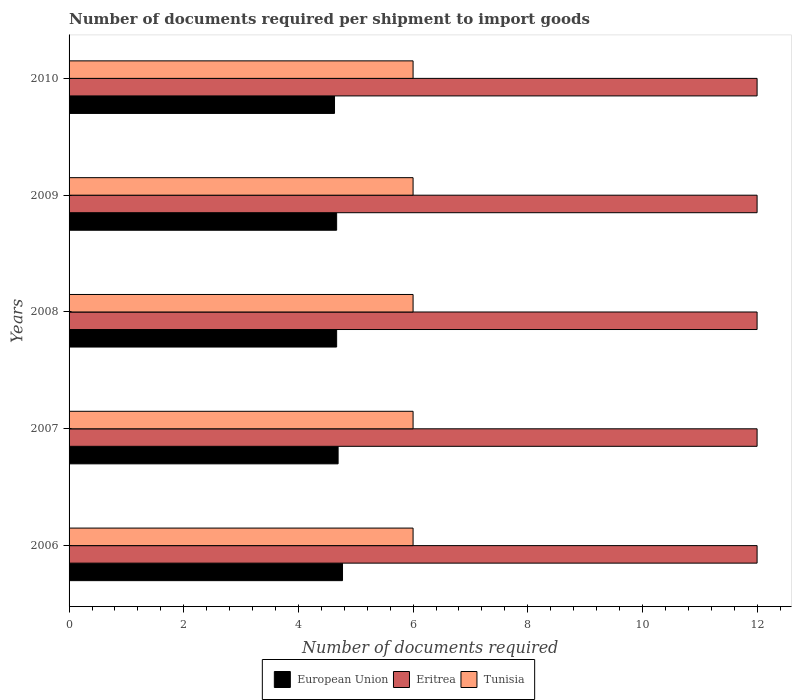How many different coloured bars are there?
Keep it short and to the point. 3. Are the number of bars per tick equal to the number of legend labels?
Offer a terse response. Yes. Are the number of bars on each tick of the Y-axis equal?
Provide a short and direct response. Yes. What is the label of the 3rd group of bars from the top?
Ensure brevity in your answer.  2008. In how many cases, is the number of bars for a given year not equal to the number of legend labels?
Ensure brevity in your answer.  0. What is the number of documents required per shipment to import goods in Eritrea in 2009?
Provide a short and direct response. 12. Across all years, what is the maximum number of documents required per shipment to import goods in Eritrea?
Your response must be concise. 12. Across all years, what is the minimum number of documents required per shipment to import goods in Eritrea?
Your response must be concise. 12. In which year was the number of documents required per shipment to import goods in Tunisia maximum?
Ensure brevity in your answer.  2006. In which year was the number of documents required per shipment to import goods in Eritrea minimum?
Offer a terse response. 2006. What is the total number of documents required per shipment to import goods in Eritrea in the graph?
Offer a very short reply. 60. What is the difference between the number of documents required per shipment to import goods in Eritrea in 2006 and that in 2007?
Provide a succinct answer. 0. What is the difference between the number of documents required per shipment to import goods in Tunisia in 2008 and the number of documents required per shipment to import goods in Eritrea in 2007?
Provide a succinct answer. -6. What is the average number of documents required per shipment to import goods in Eritrea per year?
Give a very brief answer. 12. In the year 2007, what is the difference between the number of documents required per shipment to import goods in Eritrea and number of documents required per shipment to import goods in European Union?
Provide a short and direct response. 7.31. In how many years, is the number of documents required per shipment to import goods in Eritrea greater than 0.4 ?
Your answer should be compact. 5. Is the number of documents required per shipment to import goods in Eritrea in 2006 less than that in 2007?
Ensure brevity in your answer.  No. What is the difference between the highest and the second highest number of documents required per shipment to import goods in European Union?
Your answer should be very brief. 0.08. What is the difference between the highest and the lowest number of documents required per shipment to import goods in Eritrea?
Your answer should be very brief. 0. What does the 1st bar from the top in 2006 represents?
Offer a terse response. Tunisia. What does the 2nd bar from the bottom in 2006 represents?
Your answer should be compact. Eritrea. How many years are there in the graph?
Provide a short and direct response. 5. Are the values on the major ticks of X-axis written in scientific E-notation?
Offer a very short reply. No. How many legend labels are there?
Make the answer very short. 3. How are the legend labels stacked?
Your response must be concise. Horizontal. What is the title of the graph?
Your answer should be very brief. Number of documents required per shipment to import goods. What is the label or title of the X-axis?
Keep it short and to the point. Number of documents required. What is the Number of documents required in European Union in 2006?
Keep it short and to the point. 4.77. What is the Number of documents required of European Union in 2007?
Ensure brevity in your answer.  4.69. What is the Number of documents required of Eritrea in 2007?
Offer a very short reply. 12. What is the Number of documents required of Tunisia in 2007?
Keep it short and to the point. 6. What is the Number of documents required in European Union in 2008?
Provide a short and direct response. 4.67. What is the Number of documents required in Tunisia in 2008?
Offer a very short reply. 6. What is the Number of documents required in European Union in 2009?
Provide a short and direct response. 4.67. What is the Number of documents required in Tunisia in 2009?
Offer a terse response. 6. What is the Number of documents required in European Union in 2010?
Your answer should be compact. 4.63. What is the Number of documents required in Eritrea in 2010?
Make the answer very short. 12. Across all years, what is the maximum Number of documents required in European Union?
Ensure brevity in your answer.  4.77. Across all years, what is the maximum Number of documents required of Eritrea?
Make the answer very short. 12. Across all years, what is the maximum Number of documents required of Tunisia?
Provide a succinct answer. 6. Across all years, what is the minimum Number of documents required in European Union?
Ensure brevity in your answer.  4.63. Across all years, what is the minimum Number of documents required in Eritrea?
Ensure brevity in your answer.  12. Across all years, what is the minimum Number of documents required in Tunisia?
Give a very brief answer. 6. What is the total Number of documents required in European Union in the graph?
Provide a short and direct response. 23.42. What is the difference between the Number of documents required in European Union in 2006 and that in 2007?
Provide a short and direct response. 0.08. What is the difference between the Number of documents required in European Union in 2006 and that in 2008?
Offer a very short reply. 0.1. What is the difference between the Number of documents required in Eritrea in 2006 and that in 2008?
Make the answer very short. 0. What is the difference between the Number of documents required in Tunisia in 2006 and that in 2008?
Your answer should be very brief. 0. What is the difference between the Number of documents required in European Union in 2006 and that in 2009?
Offer a very short reply. 0.1. What is the difference between the Number of documents required in Eritrea in 2006 and that in 2009?
Keep it short and to the point. 0. What is the difference between the Number of documents required in European Union in 2006 and that in 2010?
Offer a very short reply. 0.14. What is the difference between the Number of documents required of Eritrea in 2006 and that in 2010?
Provide a short and direct response. 0. What is the difference between the Number of documents required of European Union in 2007 and that in 2008?
Offer a terse response. 0.03. What is the difference between the Number of documents required in European Union in 2007 and that in 2009?
Offer a terse response. 0.03. What is the difference between the Number of documents required of Eritrea in 2007 and that in 2009?
Your answer should be very brief. 0. What is the difference between the Number of documents required of Tunisia in 2007 and that in 2009?
Provide a short and direct response. 0. What is the difference between the Number of documents required in European Union in 2007 and that in 2010?
Your answer should be compact. 0.06. What is the difference between the Number of documents required of Eritrea in 2007 and that in 2010?
Your response must be concise. 0. What is the difference between the Number of documents required of Tunisia in 2007 and that in 2010?
Offer a very short reply. 0. What is the difference between the Number of documents required of European Union in 2008 and that in 2009?
Your response must be concise. 0. What is the difference between the Number of documents required of European Union in 2008 and that in 2010?
Your response must be concise. 0.04. What is the difference between the Number of documents required in European Union in 2009 and that in 2010?
Give a very brief answer. 0.04. What is the difference between the Number of documents required of Tunisia in 2009 and that in 2010?
Your answer should be compact. 0. What is the difference between the Number of documents required of European Union in 2006 and the Number of documents required of Eritrea in 2007?
Keep it short and to the point. -7.23. What is the difference between the Number of documents required of European Union in 2006 and the Number of documents required of Tunisia in 2007?
Provide a succinct answer. -1.23. What is the difference between the Number of documents required in Eritrea in 2006 and the Number of documents required in Tunisia in 2007?
Your answer should be very brief. 6. What is the difference between the Number of documents required in European Union in 2006 and the Number of documents required in Eritrea in 2008?
Keep it short and to the point. -7.23. What is the difference between the Number of documents required in European Union in 2006 and the Number of documents required in Tunisia in 2008?
Provide a succinct answer. -1.23. What is the difference between the Number of documents required in European Union in 2006 and the Number of documents required in Eritrea in 2009?
Make the answer very short. -7.23. What is the difference between the Number of documents required of European Union in 2006 and the Number of documents required of Tunisia in 2009?
Your answer should be compact. -1.23. What is the difference between the Number of documents required in European Union in 2006 and the Number of documents required in Eritrea in 2010?
Your response must be concise. -7.23. What is the difference between the Number of documents required of European Union in 2006 and the Number of documents required of Tunisia in 2010?
Offer a very short reply. -1.23. What is the difference between the Number of documents required of Eritrea in 2006 and the Number of documents required of Tunisia in 2010?
Provide a short and direct response. 6. What is the difference between the Number of documents required of European Union in 2007 and the Number of documents required of Eritrea in 2008?
Give a very brief answer. -7.31. What is the difference between the Number of documents required of European Union in 2007 and the Number of documents required of Tunisia in 2008?
Give a very brief answer. -1.31. What is the difference between the Number of documents required of Eritrea in 2007 and the Number of documents required of Tunisia in 2008?
Make the answer very short. 6. What is the difference between the Number of documents required in European Union in 2007 and the Number of documents required in Eritrea in 2009?
Make the answer very short. -7.31. What is the difference between the Number of documents required in European Union in 2007 and the Number of documents required in Tunisia in 2009?
Provide a short and direct response. -1.31. What is the difference between the Number of documents required of Eritrea in 2007 and the Number of documents required of Tunisia in 2009?
Your answer should be very brief. 6. What is the difference between the Number of documents required of European Union in 2007 and the Number of documents required of Eritrea in 2010?
Your answer should be very brief. -7.31. What is the difference between the Number of documents required in European Union in 2007 and the Number of documents required in Tunisia in 2010?
Your response must be concise. -1.31. What is the difference between the Number of documents required in Eritrea in 2007 and the Number of documents required in Tunisia in 2010?
Give a very brief answer. 6. What is the difference between the Number of documents required in European Union in 2008 and the Number of documents required in Eritrea in 2009?
Offer a terse response. -7.33. What is the difference between the Number of documents required in European Union in 2008 and the Number of documents required in Tunisia in 2009?
Provide a succinct answer. -1.33. What is the difference between the Number of documents required of European Union in 2008 and the Number of documents required of Eritrea in 2010?
Your answer should be compact. -7.33. What is the difference between the Number of documents required in European Union in 2008 and the Number of documents required in Tunisia in 2010?
Offer a terse response. -1.33. What is the difference between the Number of documents required of Eritrea in 2008 and the Number of documents required of Tunisia in 2010?
Ensure brevity in your answer.  6. What is the difference between the Number of documents required in European Union in 2009 and the Number of documents required in Eritrea in 2010?
Your response must be concise. -7.33. What is the difference between the Number of documents required of European Union in 2009 and the Number of documents required of Tunisia in 2010?
Offer a terse response. -1.33. What is the difference between the Number of documents required of Eritrea in 2009 and the Number of documents required of Tunisia in 2010?
Ensure brevity in your answer.  6. What is the average Number of documents required in European Union per year?
Provide a succinct answer. 4.68. What is the average Number of documents required of Tunisia per year?
Your answer should be compact. 6. In the year 2006, what is the difference between the Number of documents required of European Union and Number of documents required of Eritrea?
Your response must be concise. -7.23. In the year 2006, what is the difference between the Number of documents required in European Union and Number of documents required in Tunisia?
Your answer should be compact. -1.23. In the year 2006, what is the difference between the Number of documents required of Eritrea and Number of documents required of Tunisia?
Your response must be concise. 6. In the year 2007, what is the difference between the Number of documents required of European Union and Number of documents required of Eritrea?
Offer a terse response. -7.31. In the year 2007, what is the difference between the Number of documents required of European Union and Number of documents required of Tunisia?
Ensure brevity in your answer.  -1.31. In the year 2007, what is the difference between the Number of documents required in Eritrea and Number of documents required in Tunisia?
Make the answer very short. 6. In the year 2008, what is the difference between the Number of documents required in European Union and Number of documents required in Eritrea?
Make the answer very short. -7.33. In the year 2008, what is the difference between the Number of documents required in European Union and Number of documents required in Tunisia?
Offer a terse response. -1.33. In the year 2008, what is the difference between the Number of documents required in Eritrea and Number of documents required in Tunisia?
Your answer should be compact. 6. In the year 2009, what is the difference between the Number of documents required of European Union and Number of documents required of Eritrea?
Offer a very short reply. -7.33. In the year 2009, what is the difference between the Number of documents required in European Union and Number of documents required in Tunisia?
Provide a short and direct response. -1.33. In the year 2010, what is the difference between the Number of documents required of European Union and Number of documents required of Eritrea?
Make the answer very short. -7.37. In the year 2010, what is the difference between the Number of documents required of European Union and Number of documents required of Tunisia?
Offer a very short reply. -1.37. What is the ratio of the Number of documents required in European Union in 2006 to that in 2007?
Make the answer very short. 1.02. What is the ratio of the Number of documents required of Tunisia in 2006 to that in 2007?
Provide a succinct answer. 1. What is the ratio of the Number of documents required of Eritrea in 2006 to that in 2008?
Your answer should be very brief. 1. What is the ratio of the Number of documents required in Tunisia in 2006 to that in 2008?
Your answer should be very brief. 1. What is the ratio of the Number of documents required of European Union in 2006 to that in 2009?
Your answer should be compact. 1.02. What is the ratio of the Number of documents required in Eritrea in 2006 to that in 2009?
Your answer should be compact. 1. What is the ratio of the Number of documents required in European Union in 2006 to that in 2010?
Your answer should be compact. 1.03. What is the ratio of the Number of documents required of Tunisia in 2006 to that in 2010?
Ensure brevity in your answer.  1. What is the ratio of the Number of documents required in Tunisia in 2007 to that in 2008?
Ensure brevity in your answer.  1. What is the ratio of the Number of documents required in European Union in 2007 to that in 2009?
Offer a terse response. 1.01. What is the ratio of the Number of documents required in Eritrea in 2007 to that in 2009?
Your response must be concise. 1. What is the ratio of the Number of documents required of Tunisia in 2007 to that in 2009?
Offer a terse response. 1. What is the ratio of the Number of documents required of European Union in 2007 to that in 2010?
Make the answer very short. 1.01. What is the ratio of the Number of documents required in Tunisia in 2008 to that in 2009?
Give a very brief answer. 1. What is the ratio of the Number of documents required in Tunisia in 2008 to that in 2010?
Offer a terse response. 1. What is the ratio of the Number of documents required of European Union in 2009 to that in 2010?
Keep it short and to the point. 1.01. What is the difference between the highest and the second highest Number of documents required of European Union?
Your response must be concise. 0.08. What is the difference between the highest and the lowest Number of documents required of European Union?
Offer a very short reply. 0.14. What is the difference between the highest and the lowest Number of documents required in Eritrea?
Make the answer very short. 0. What is the difference between the highest and the lowest Number of documents required of Tunisia?
Provide a succinct answer. 0. 